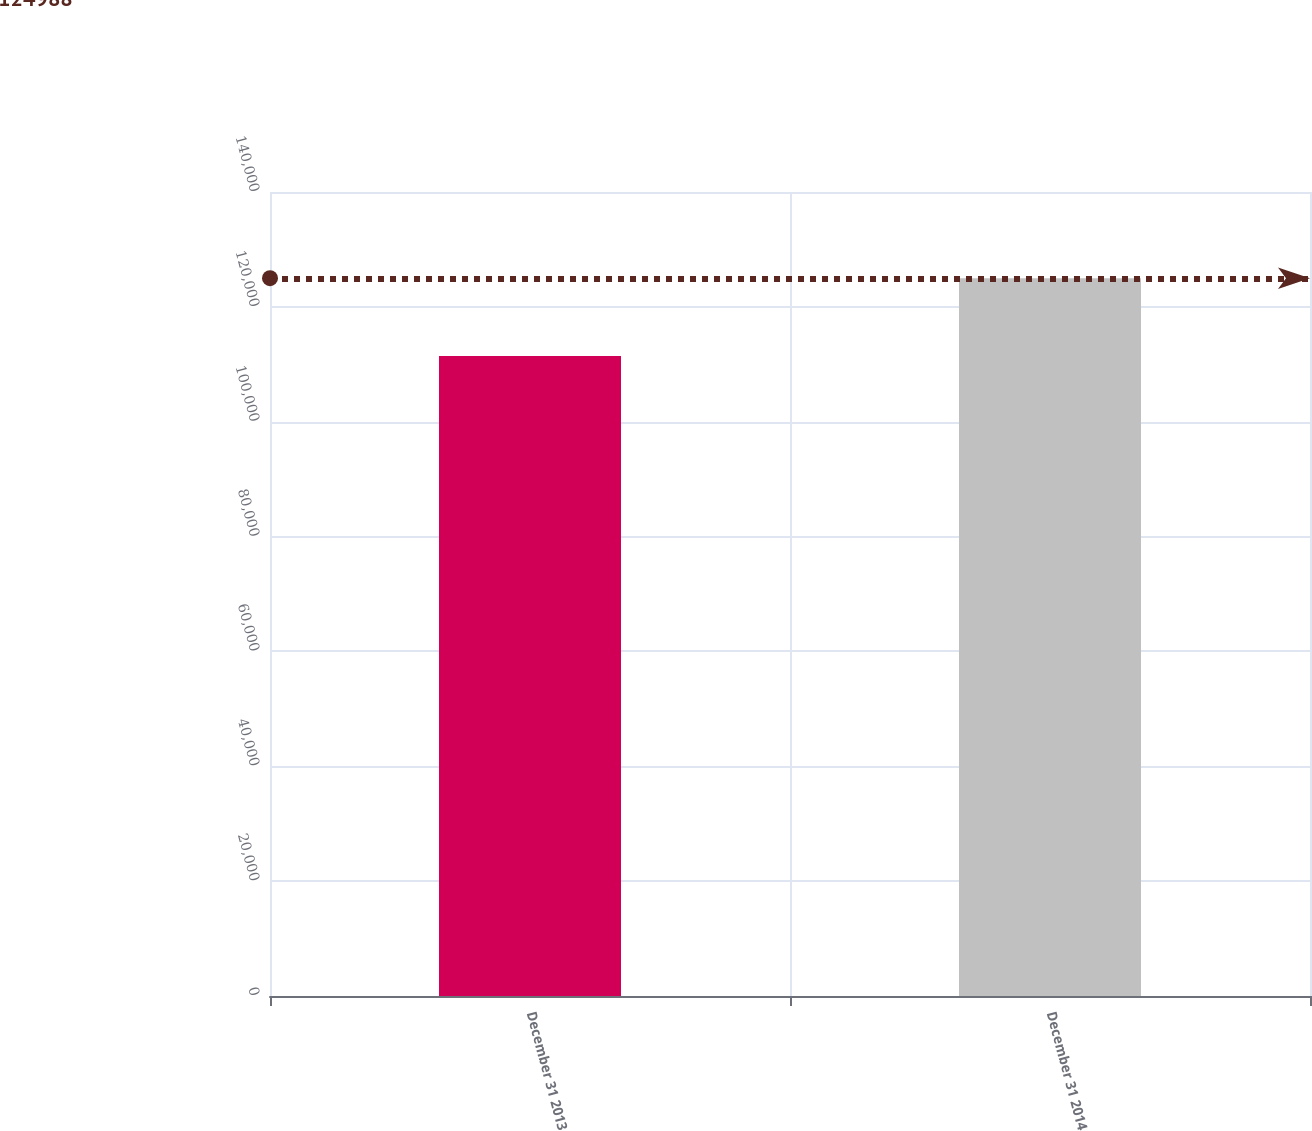Convert chart. <chart><loc_0><loc_0><loc_500><loc_500><bar_chart><fcel>December 31 2013<fcel>December 31 2014<nl><fcel>111450<fcel>124988<nl></chart> 